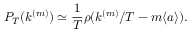Convert formula to latex. <formula><loc_0><loc_0><loc_500><loc_500>P _ { T } ( k ^ { ( m ) } ) \simeq \frac { 1 } { T } \rho ( k ^ { ( m ) } / T - m \langle a \rangle ) .</formula> 